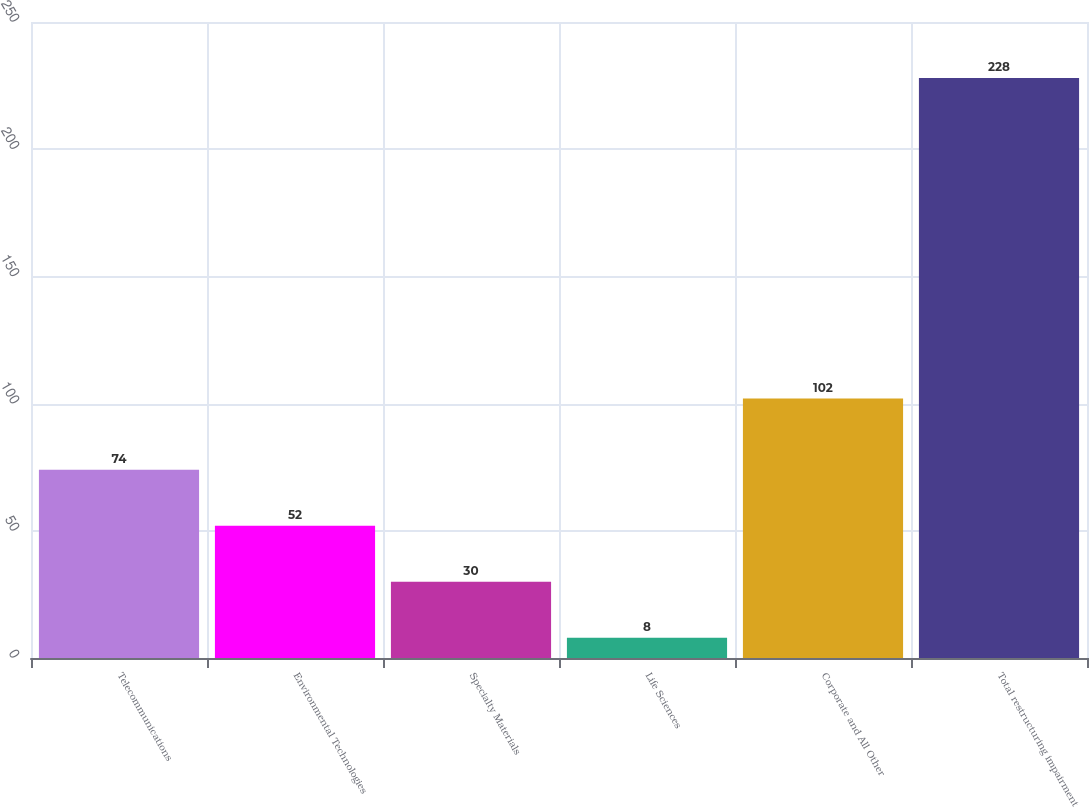Convert chart to OTSL. <chart><loc_0><loc_0><loc_500><loc_500><bar_chart><fcel>Telecommunications<fcel>Environmental Technologies<fcel>Specialty Materials<fcel>Life Sciences<fcel>Corporate and All Other<fcel>Total restructuring impairment<nl><fcel>74<fcel>52<fcel>30<fcel>8<fcel>102<fcel>228<nl></chart> 